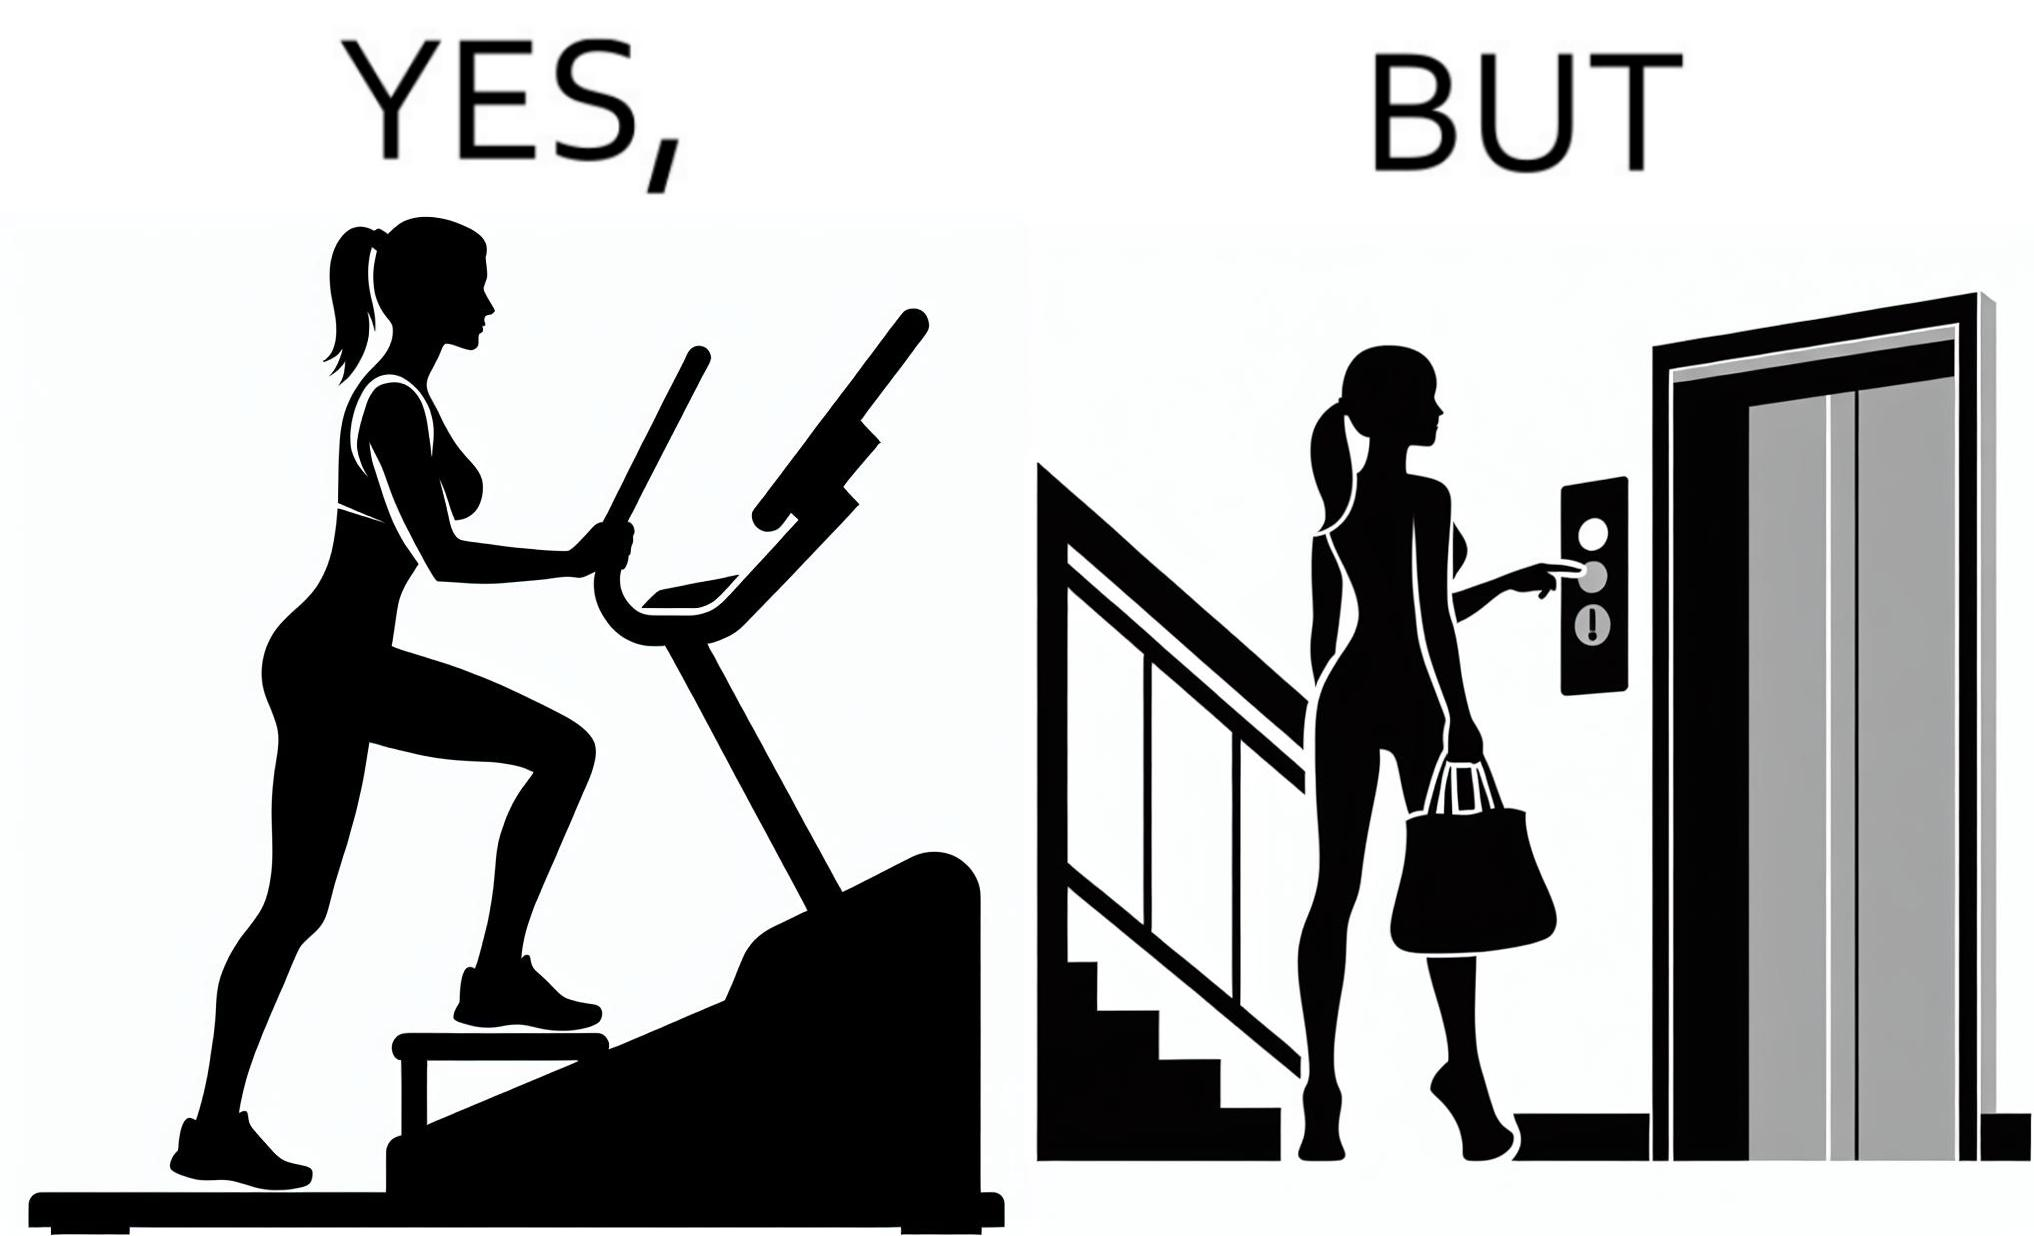Explain why this image is satirical. The image is ironic, because in the left image a woman is seen using the stair climber machine at the gym but the same woman is not ready to climb up some stairs for going to the gym and is calling for the lift 